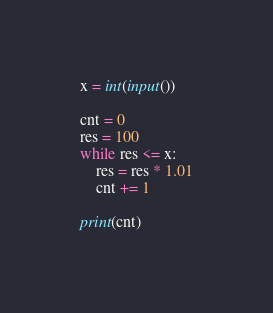<code> <loc_0><loc_0><loc_500><loc_500><_Python_>x = int(input()) 

cnt = 0
res = 100
while res <= x:
    res = res * 1.01
    cnt += 1

print(cnt)


</code> 